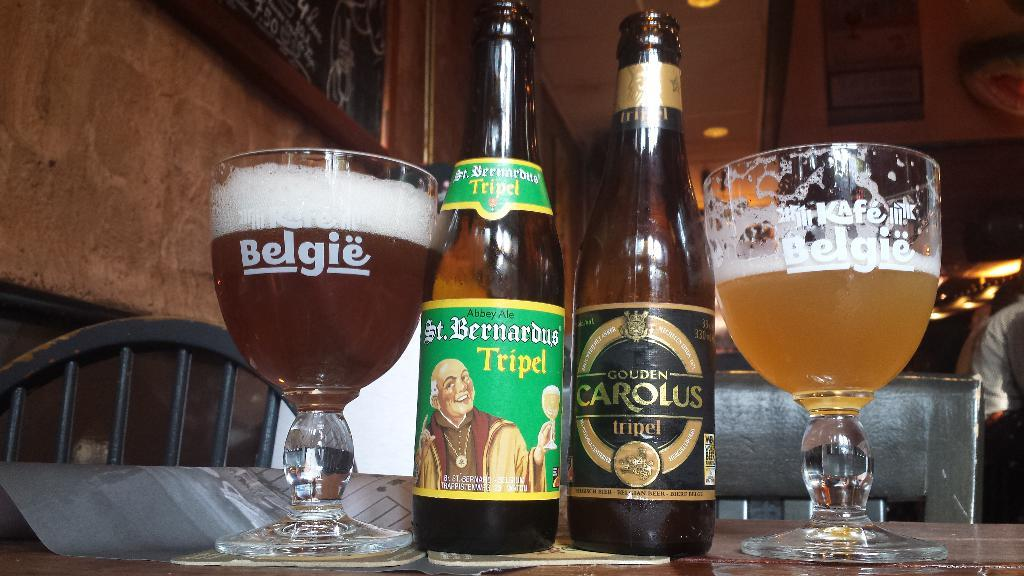<image>
Write a terse but informative summary of the picture. Two bottles of St. Bernardus Tripel beer and Gouden Carlous Tripel beer are by two full glasses. 